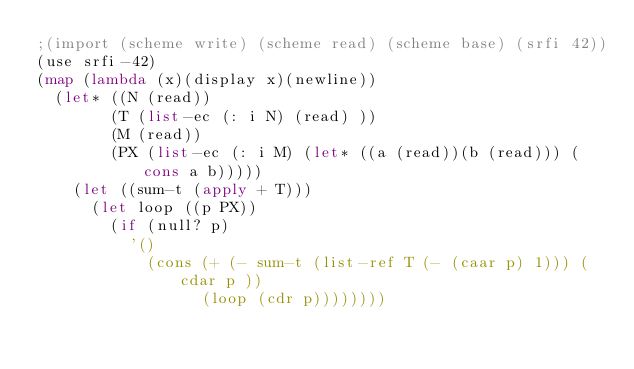Convert code to text. <code><loc_0><loc_0><loc_500><loc_500><_Scheme_>;(import (scheme write) (scheme read) (scheme base) (srfi 42))
(use srfi-42)
(map (lambda (x)(display x)(newline))
  (let* ((N (read))
        (T (list-ec (: i N) (read) ))
        (M (read))
        (PX (list-ec (: i M) (let* ((a (read))(b (read))) (cons a b)))))
    (let ((sum-t (apply + T)))
      (let loop ((p PX))
        (if (null? p)
          '()
            (cons (+ (- sum-t (list-ref T (- (caar p) 1))) (cdar p ))
                  (loop (cdr p))))))))
</code> 